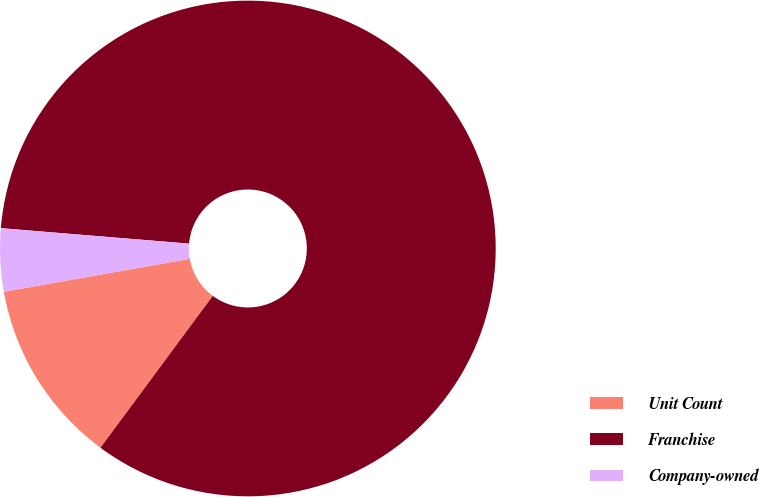<chart> <loc_0><loc_0><loc_500><loc_500><pie_chart><fcel>Unit Count<fcel>Franchise<fcel>Company-owned<nl><fcel>12.07%<fcel>83.83%<fcel>4.1%<nl></chart> 